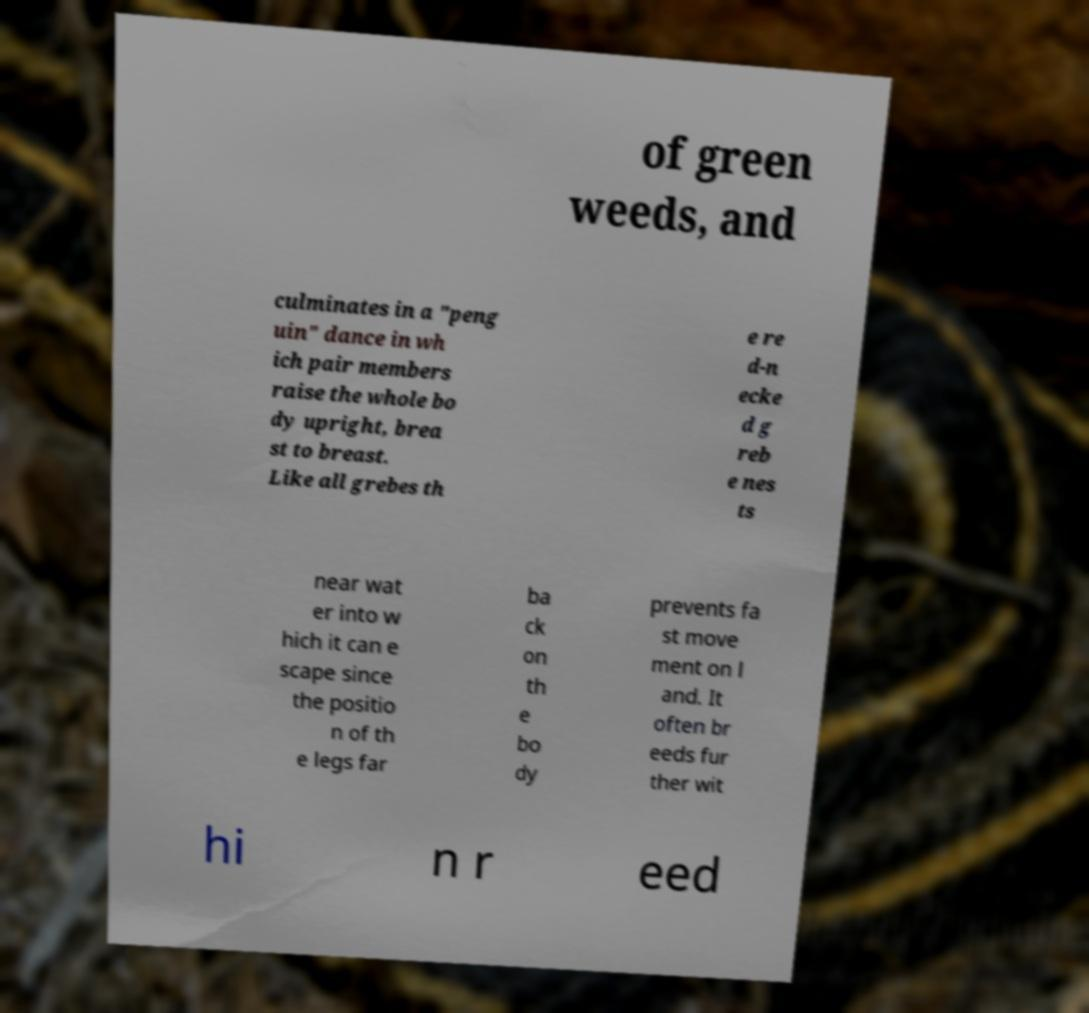Please read and relay the text visible in this image. What does it say? of green weeds, and culminates in a "peng uin" dance in wh ich pair members raise the whole bo dy upright, brea st to breast. Like all grebes th e re d-n ecke d g reb e nes ts near wat er into w hich it can e scape since the positio n of th e legs far ba ck on th e bo dy prevents fa st move ment on l and. It often br eeds fur ther wit hi n r eed 